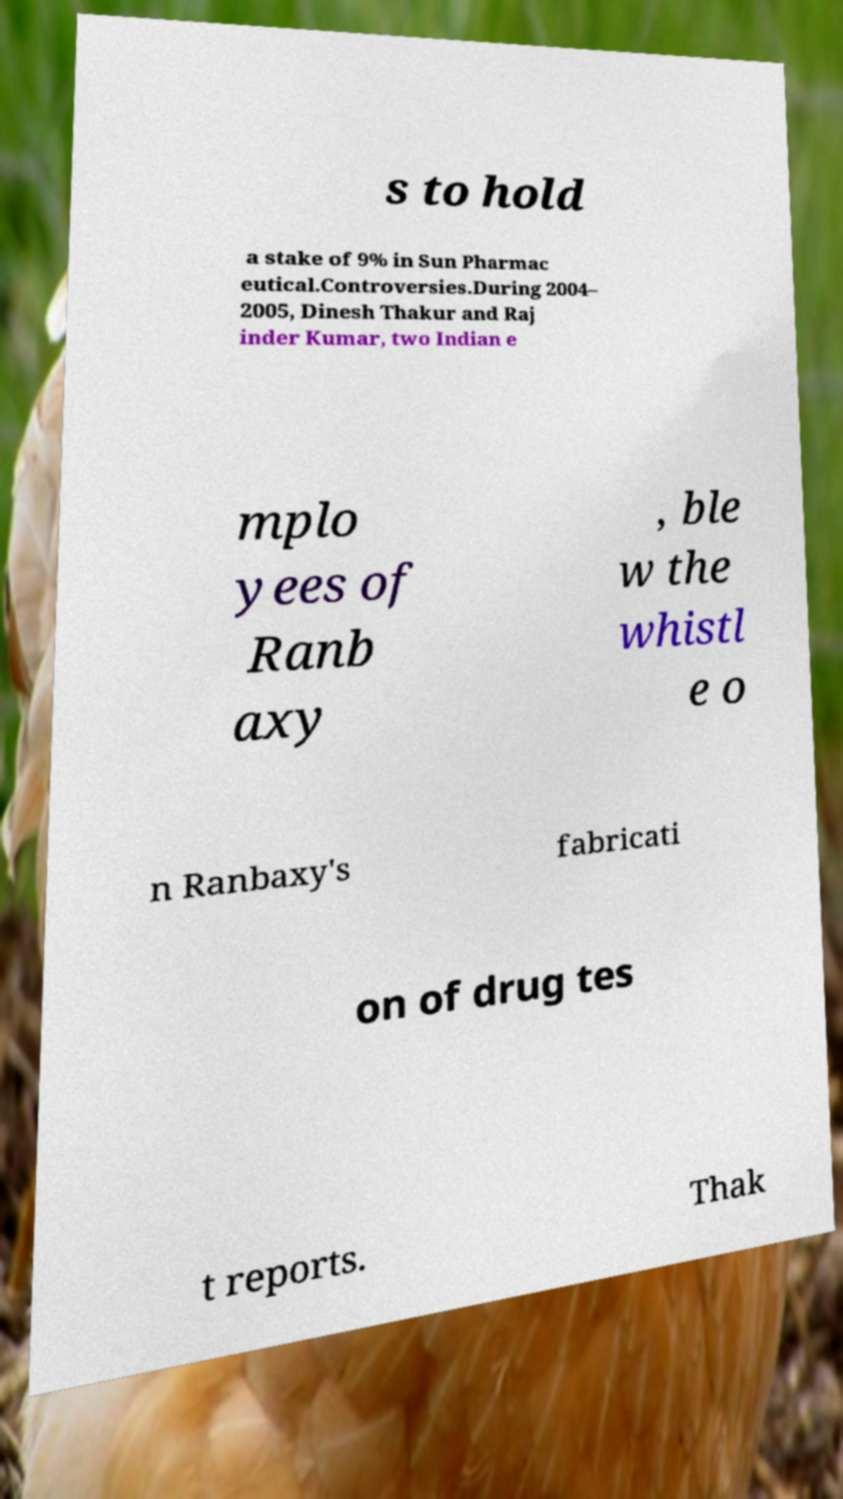Can you read and provide the text displayed in the image?This photo seems to have some interesting text. Can you extract and type it out for me? s to hold a stake of 9% in Sun Pharmac eutical.Controversies.During 2004– 2005, Dinesh Thakur and Raj inder Kumar, two Indian e mplo yees of Ranb axy , ble w the whistl e o n Ranbaxy's fabricati on of drug tes t reports. Thak 